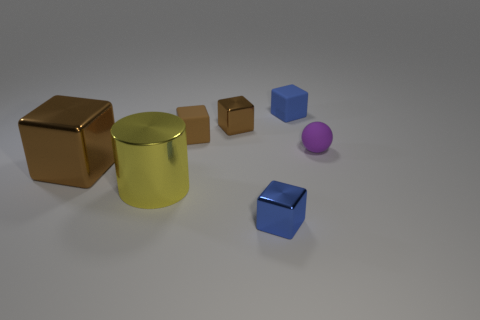What number of gray things are either rubber spheres or matte cubes?
Provide a succinct answer. 0. The metal block that is both right of the yellow shiny cylinder and left of the blue metal block is what color?
Provide a short and direct response. Brown. Is the material of the small cube that is in front of the purple matte thing the same as the thing on the left side of the cylinder?
Your answer should be very brief. Yes. Is the number of blocks to the right of the big yellow thing greater than the number of tiny blue matte cubes that are in front of the big brown thing?
Provide a short and direct response. Yes. There is a blue matte object that is the same size as the sphere; what is its shape?
Give a very brief answer. Cube. How many things are either small green cylinders or objects that are behind the small blue shiny cube?
Provide a short and direct response. 6. There is a large brown block; how many big metal cylinders are in front of it?
Make the answer very short. 1. What color is the big cylinder that is made of the same material as the large brown object?
Keep it short and to the point. Yellow. How many matte things are yellow cylinders or small purple spheres?
Offer a terse response. 1. Do the yellow object and the big brown object have the same material?
Provide a succinct answer. Yes. 